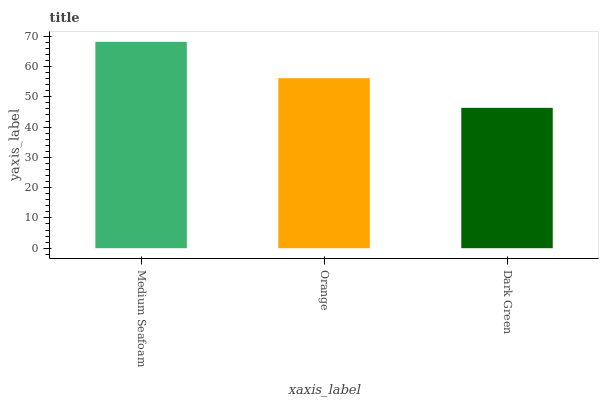Is Dark Green the minimum?
Answer yes or no. Yes. Is Medium Seafoam the maximum?
Answer yes or no. Yes. Is Orange the minimum?
Answer yes or no. No. Is Orange the maximum?
Answer yes or no. No. Is Medium Seafoam greater than Orange?
Answer yes or no. Yes. Is Orange less than Medium Seafoam?
Answer yes or no. Yes. Is Orange greater than Medium Seafoam?
Answer yes or no. No. Is Medium Seafoam less than Orange?
Answer yes or no. No. Is Orange the high median?
Answer yes or no. Yes. Is Orange the low median?
Answer yes or no. Yes. Is Dark Green the high median?
Answer yes or no. No. Is Dark Green the low median?
Answer yes or no. No. 